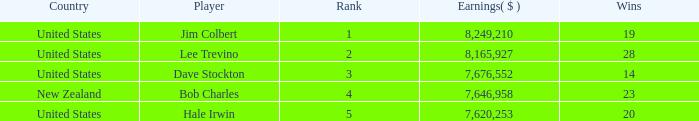How many average wins for players ranked below 2 with earnings greater than $7,676,552? None. 